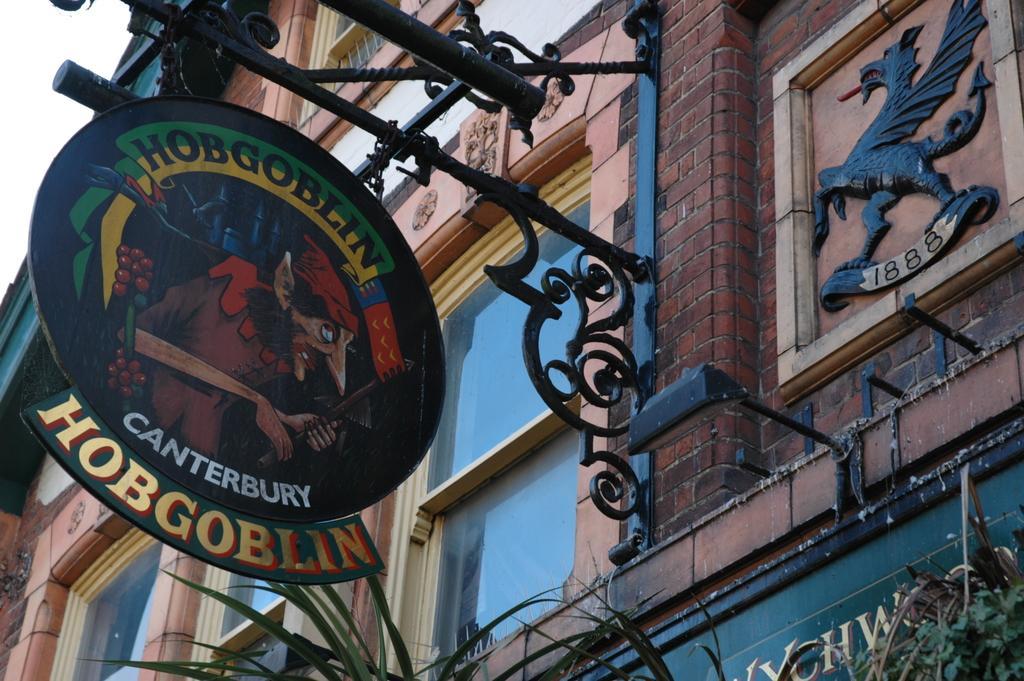Could you give a brief overview of what you see in this image? In the image there is a building with windows and name board with plants below it and above its sky. 